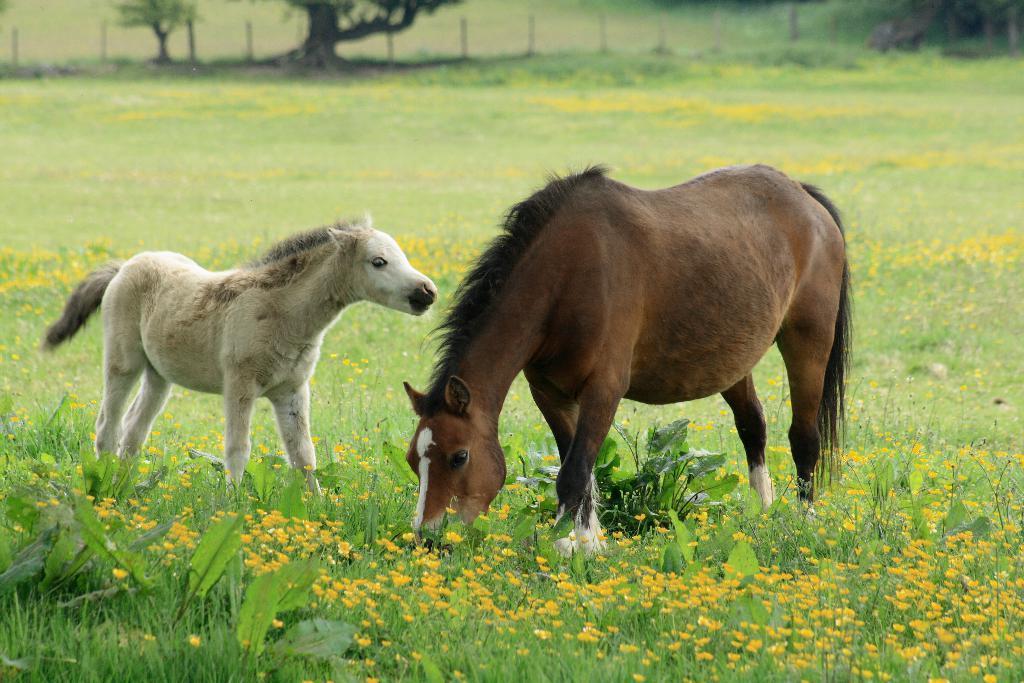How would you summarize this image in a sentence or two? In this picture we can see a horse and a foal on the grass, and also we can see few plants, flowers and trees. 